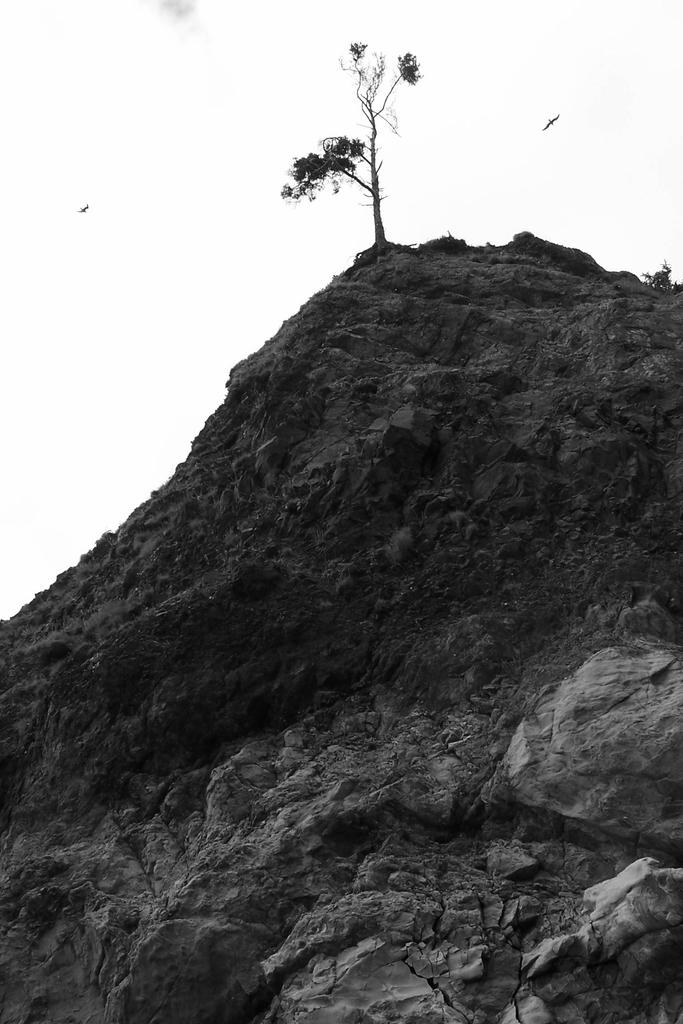What is the color scheme of the image? The image is black and white. What can be seen on the hill in the image? There are rocks on the hill and a tree on the top of the hill. What is visible in the background of the image? The sky is visible in the background. What type of tooth is visible in the image? There is no tooth present in the image. What is inside the box on the hill in the image? There is no box present in the image. 